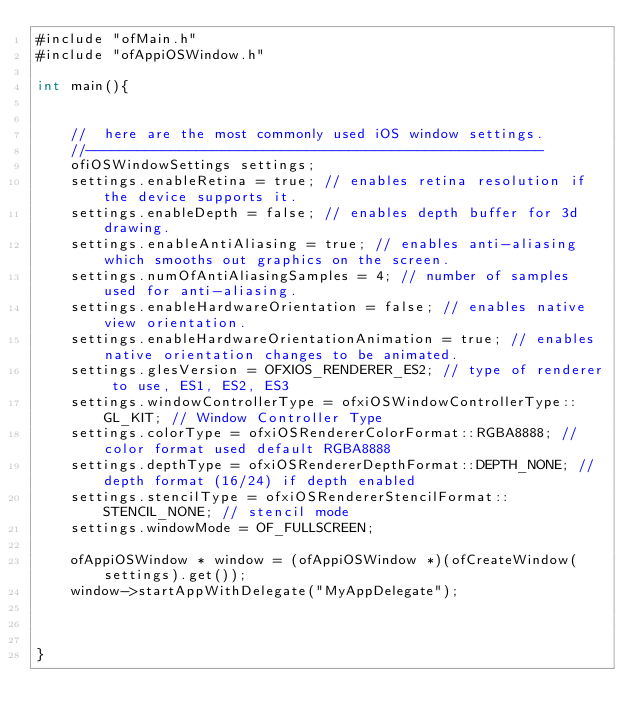<code> <loc_0><loc_0><loc_500><loc_500><_ObjectiveC_>#include "ofMain.h"
#include "ofAppiOSWindow.h"

int main(){


    //  here are the most commonly used iOS window settings.
    //------------------------------------------------------
    ofiOSWindowSettings settings;
    settings.enableRetina = true; // enables retina resolution if the device supports it.
    settings.enableDepth = false; // enables depth buffer for 3d drawing.
    settings.enableAntiAliasing = true; // enables anti-aliasing which smooths out graphics on the screen.
    settings.numOfAntiAliasingSamples = 4; // number of samples used for anti-aliasing.
    settings.enableHardwareOrientation = false; // enables native view orientation.
    settings.enableHardwareOrientationAnimation = true; // enables native orientation changes to be animated.
    settings.glesVersion = OFXIOS_RENDERER_ES2; // type of renderer to use, ES1, ES2, ES3
    settings.windowControllerType = ofxiOSWindowControllerType::GL_KIT; // Window Controller Type
    settings.colorType = ofxiOSRendererColorFormat::RGBA8888; // color format used default RGBA8888
    settings.depthType = ofxiOSRendererDepthFormat::DEPTH_NONE; // depth format (16/24) if depth enabled
    settings.stencilType = ofxiOSRendererStencilFormat::STENCIL_NONE; // stencil mode
    settings.windowMode = OF_FULLSCREEN;
    
    ofAppiOSWindow * window = (ofAppiOSWindow *)(ofCreateWindow(settings).get());
    window->startAppWithDelegate("MyAppDelegate");
    

    
}
</code> 